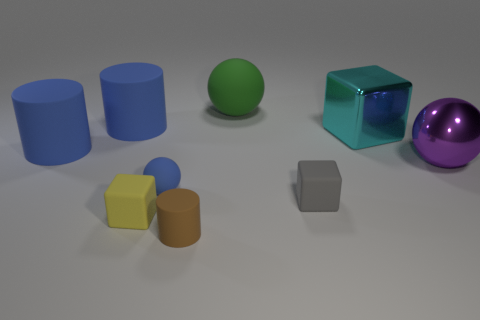Subtract all tiny cubes. How many cubes are left? 1 Subtract all cyan blocks. How many blocks are left? 2 Subtract 1 balls. How many balls are left? 2 Add 5 big green matte objects. How many big green matte objects exist? 6 Subtract 0 green blocks. How many objects are left? 9 Subtract all cylinders. How many objects are left? 6 Subtract all gray blocks. Subtract all yellow cylinders. How many blocks are left? 2 Subtract all red cubes. How many purple balls are left? 1 Subtract all brown balls. Subtract all big metallic cubes. How many objects are left? 8 Add 2 metal things. How many metal things are left? 4 